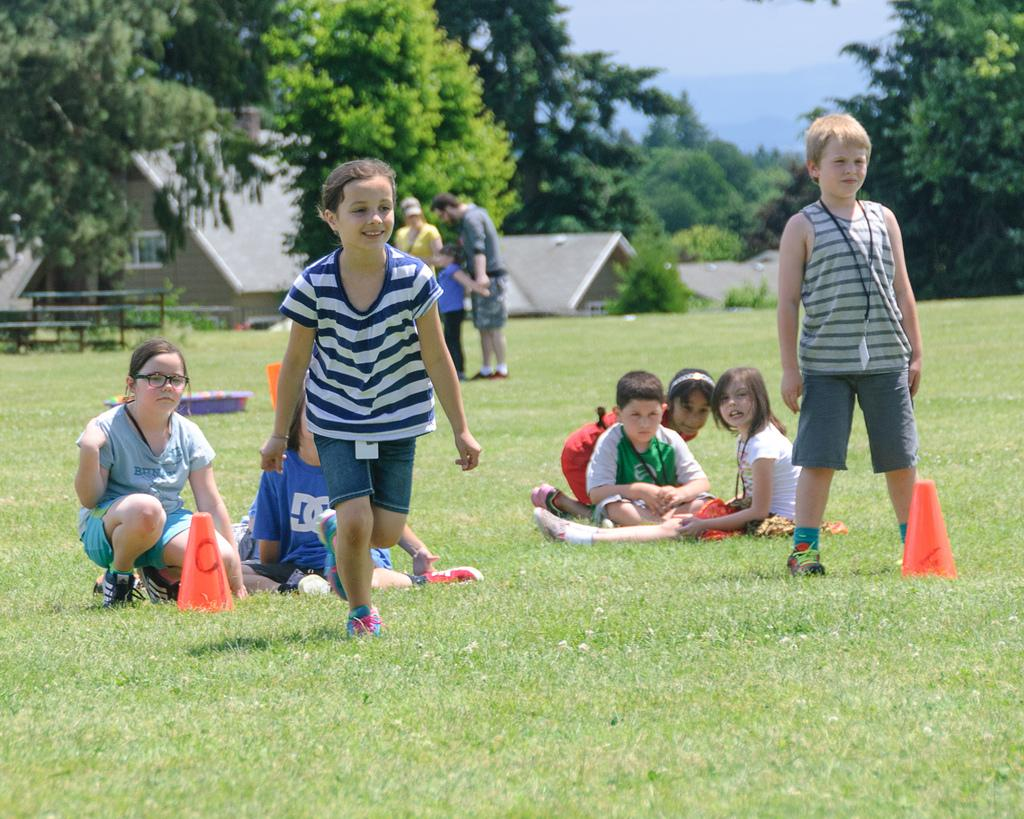What are the people in the image doing? Some people are standing, and others are sitting in the image. What is in front of the people? There are objects and grass in front of the people. What can be seen in the background of the image? There are trees, a bench, a house, and the sky visible in the background of the image. What type of nut is being cracked by the chickens in the image? There are no chickens present in the image, so there is no nut-cracking activity to observe. What type of cannon is visible in the background of the image? There is no cannon present in the image; the background features trees, a bench, a house, and the sky. 